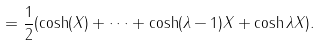<formula> <loc_0><loc_0><loc_500><loc_500>= \frac { 1 } { 2 } ( \cosh ( X ) + \dots + \cosh ( \lambda - 1 ) X + \cosh \lambda X ) .</formula> 